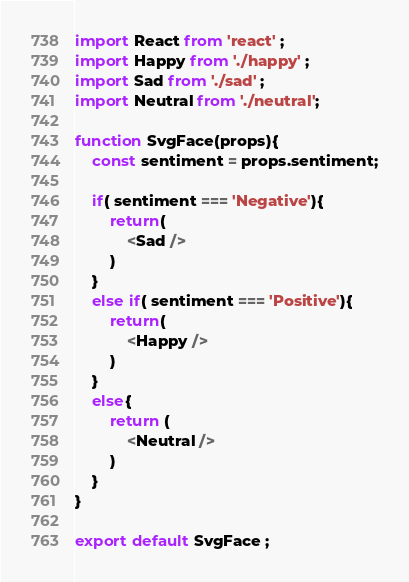<code> <loc_0><loc_0><loc_500><loc_500><_JavaScript_>import React from 'react' ;
import Happy from './happy' ;
import Sad from './sad' ;
import Neutral from './neutral';

function SvgFace(props){
    const sentiment = props.sentiment;

    if( sentiment === 'Negative'){
        return(
            <Sad />    
        )
    }
    else if( sentiment === 'Positive'){
        return(
            <Happy />
        )
    }
    else{
        return (
            <Neutral />
        )
    } 
}

export default SvgFace ;

</code> 